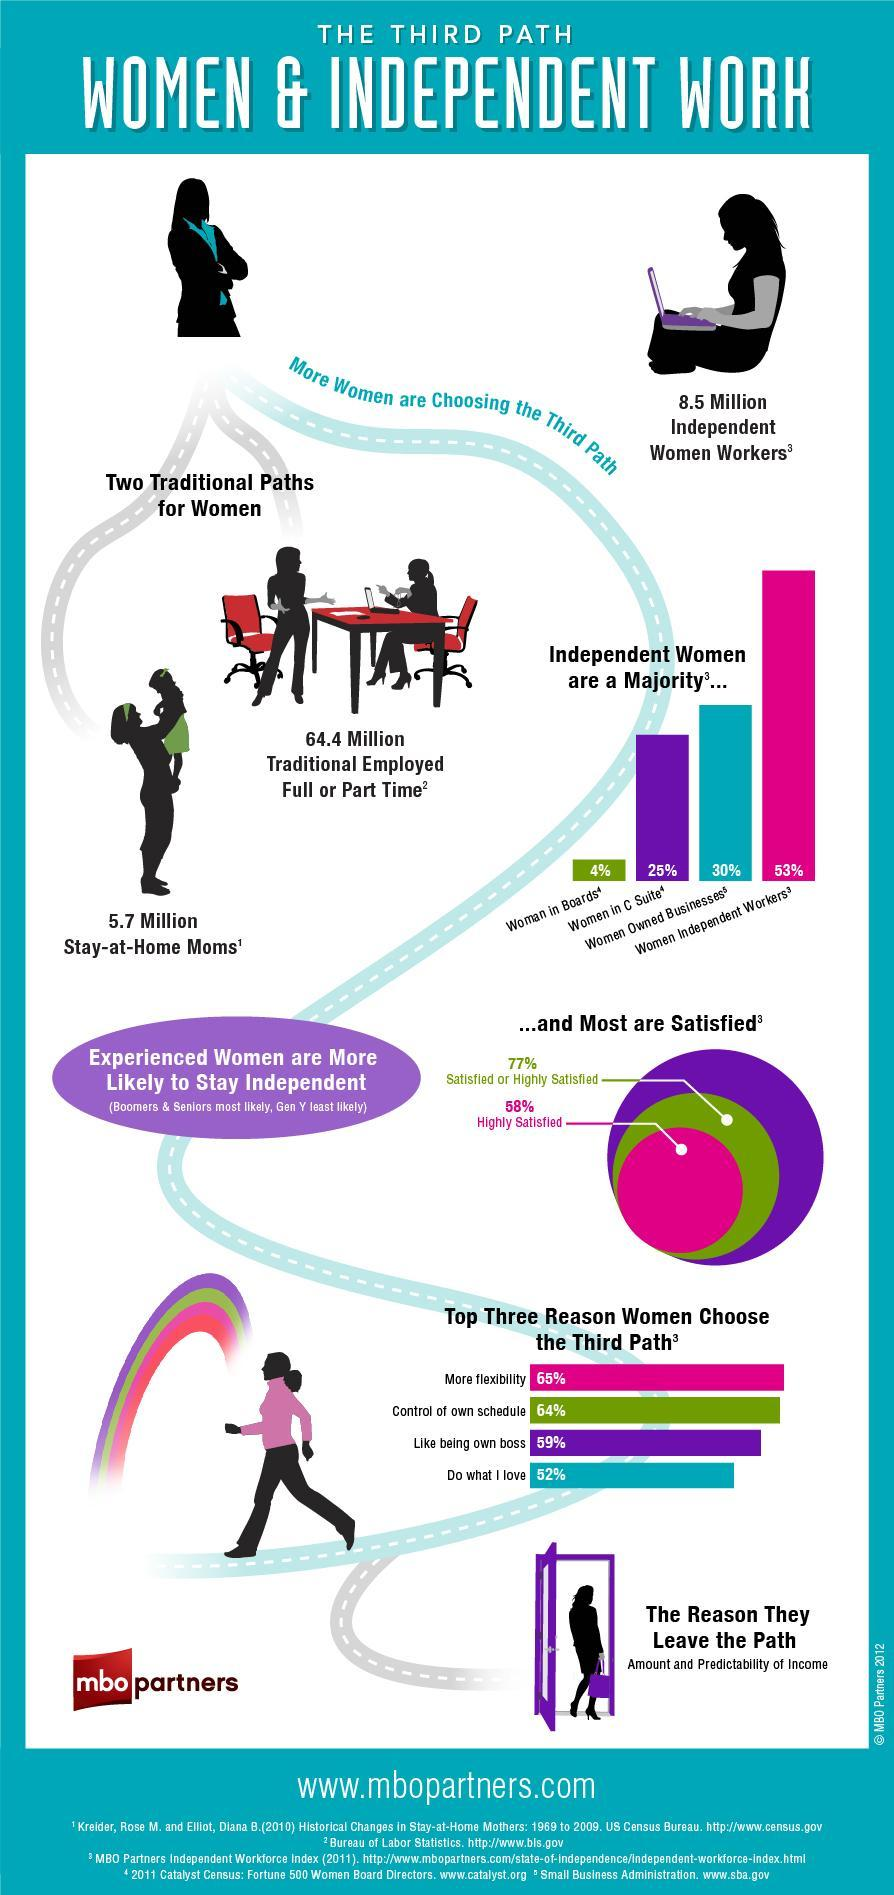How many women are full or part time employed as per the survey?
Answer the question with a short phrase. 64.4 Million What percentage of independent women workers are satisfied or highly satisfied as per the survey? 77% What percentage of independent women owned their own businesses according to the survey? 30% 